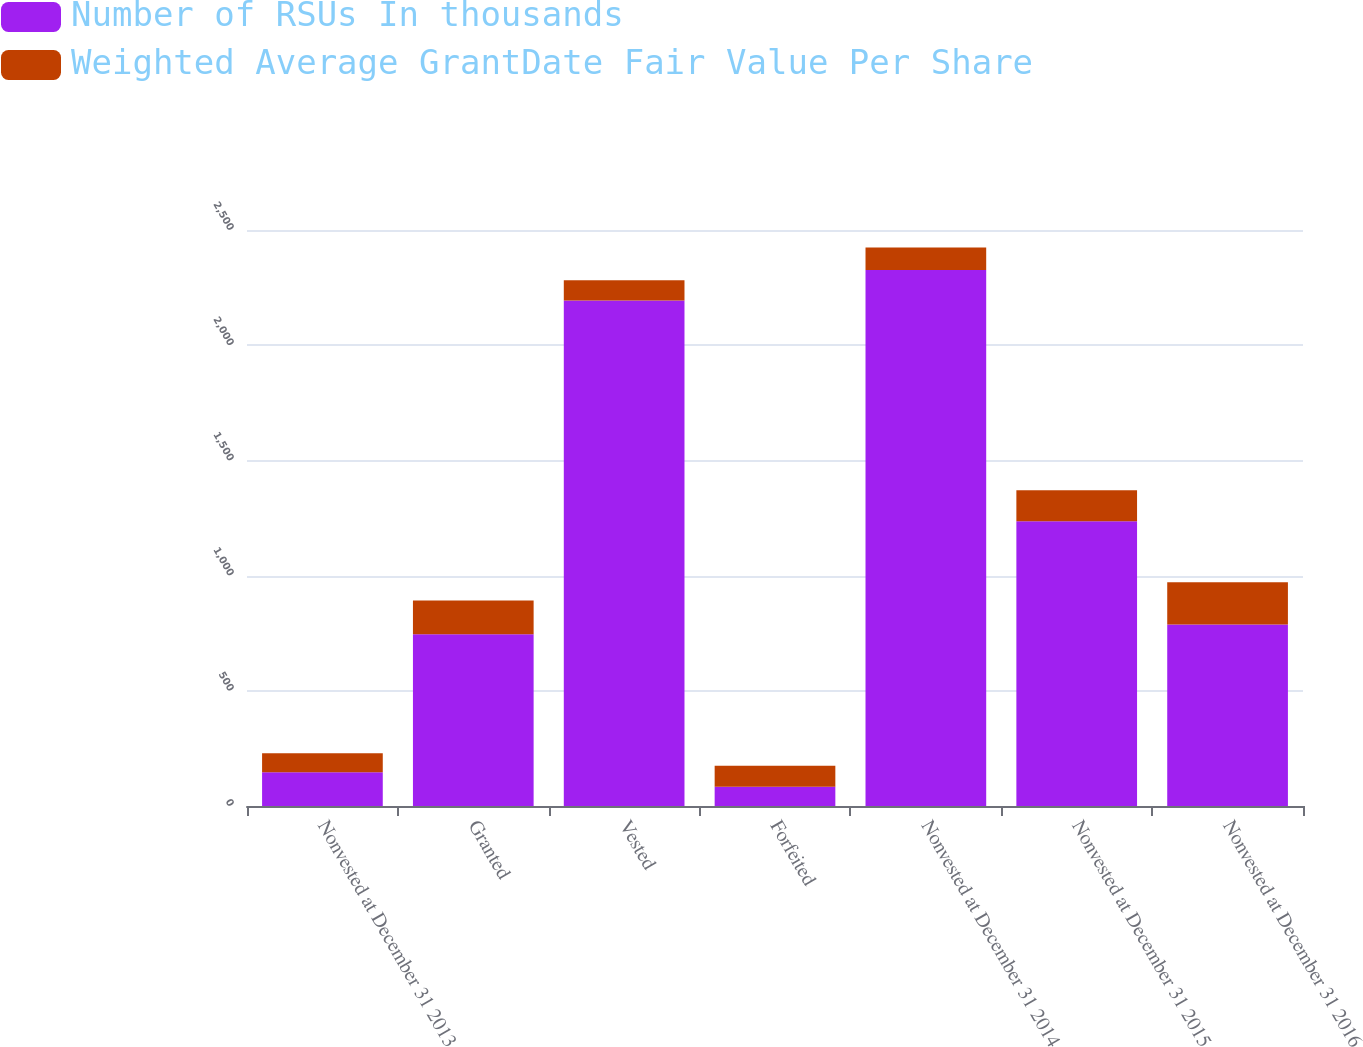Convert chart. <chart><loc_0><loc_0><loc_500><loc_500><stacked_bar_chart><ecel><fcel>Nonvested at December 31 2013<fcel>Granted<fcel>Vested<fcel>Forfeited<fcel>Nonvested at December 31 2014<fcel>Nonvested at December 31 2015<fcel>Nonvested at December 31 2016<nl><fcel>Number of RSUs In thousands<fcel>146.85<fcel>745<fcel>2194<fcel>84<fcel>2326<fcel>1236<fcel>788<nl><fcel>Weighted Average GrantDate Fair Value Per Share<fcel>82.42<fcel>146.85<fcel>87.66<fcel>91.11<fcel>97.8<fcel>134.87<fcel>183<nl></chart> 